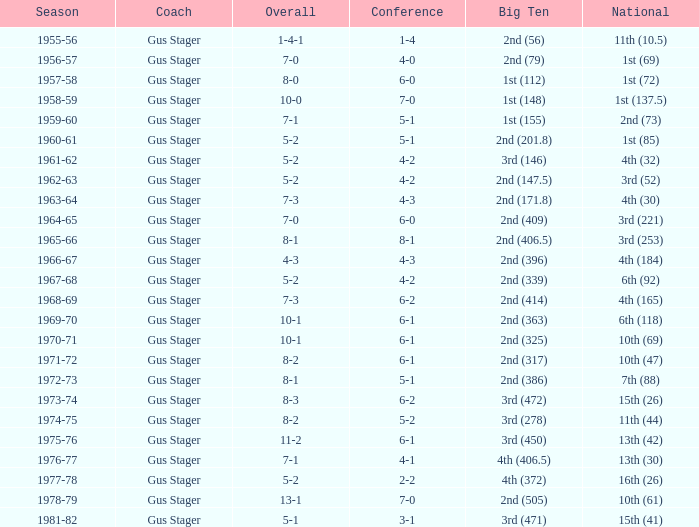What is the instructor with a big ten that is 2nd (79)? Gus Stager. 